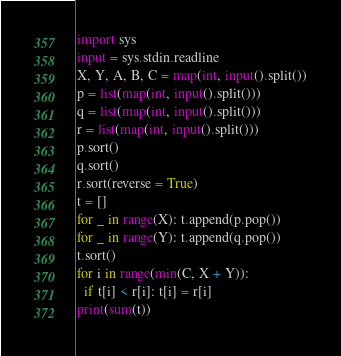Convert code to text. <code><loc_0><loc_0><loc_500><loc_500><_Python_>import sys
input = sys.stdin.readline
X, Y, A, B, C = map(int, input().split())
p = list(map(int, input().split()))
q = list(map(int, input().split()))
r = list(map(int, input().split()))
p.sort()
q.sort()
r.sort(reverse = True)
t = []
for _ in range(X): t.append(p.pop())
for _ in range(Y): t.append(q.pop())
t.sort()
for i in range(min(C, X + Y)):
  if t[i] < r[i]: t[i] = r[i]
print(sum(t))</code> 